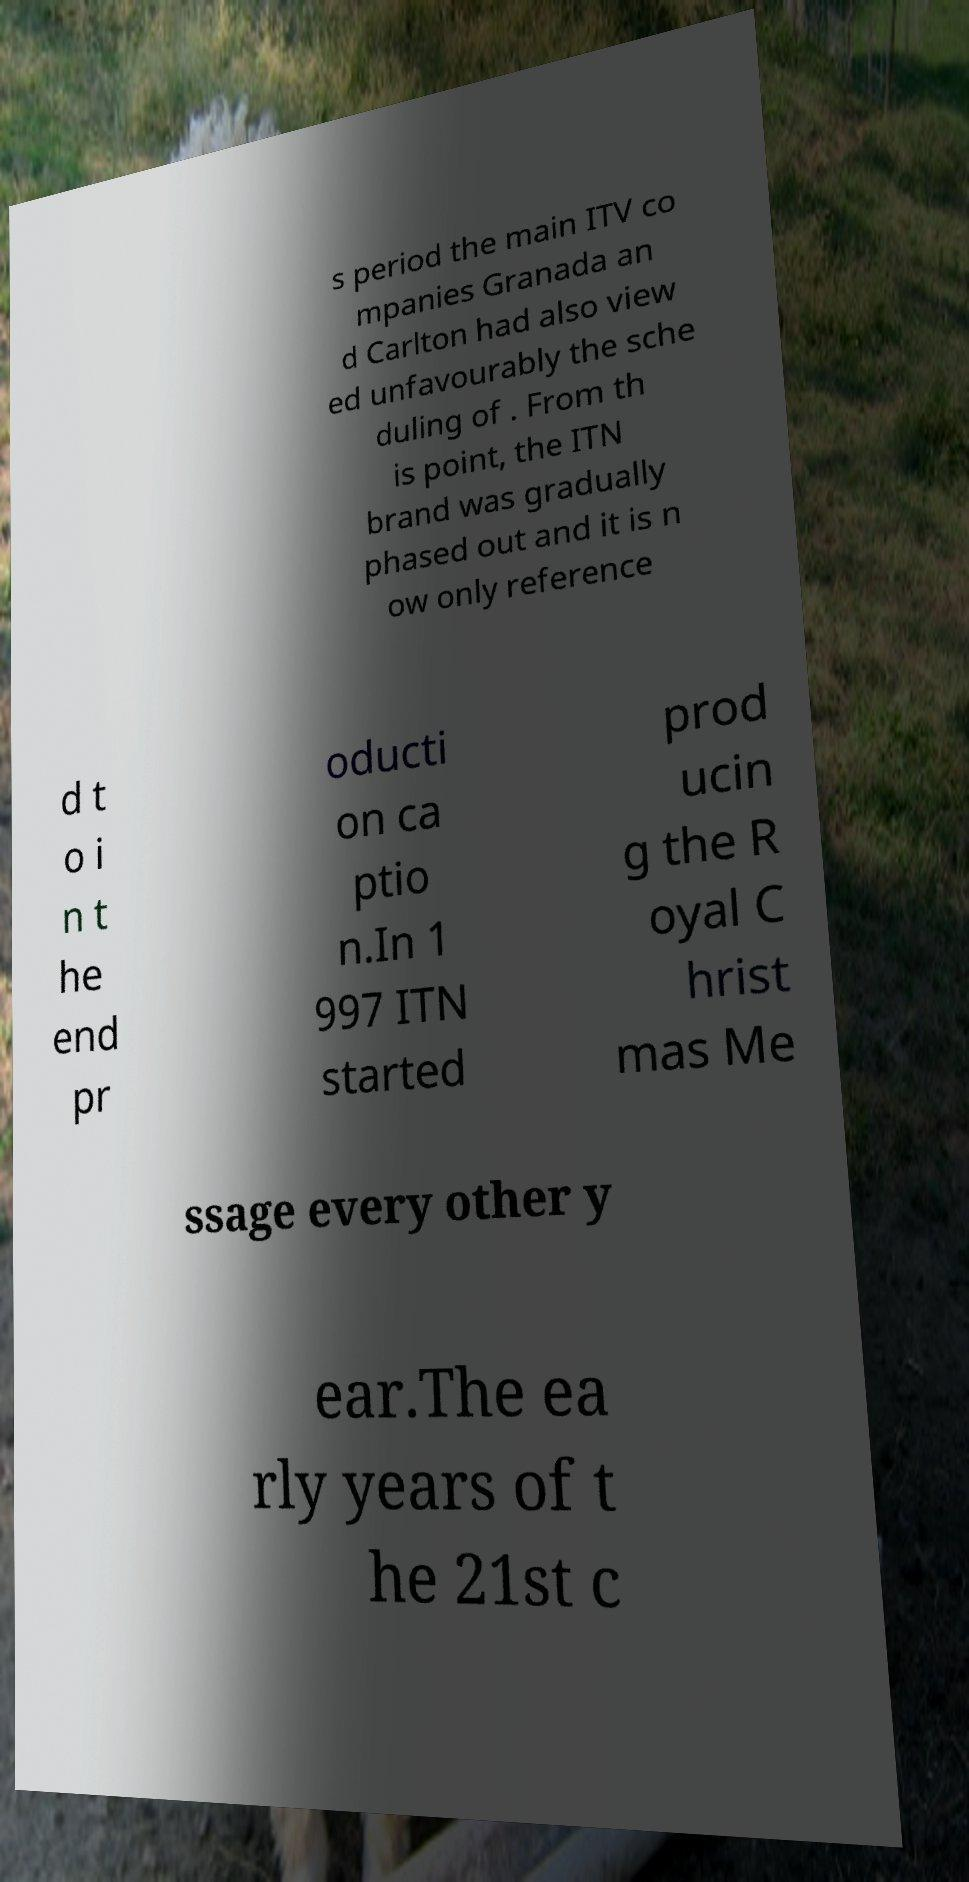Could you extract and type out the text from this image? s period the main ITV co mpanies Granada an d Carlton had also view ed unfavourably the sche duling of . From th is point, the ITN brand was gradually phased out and it is n ow only reference d t o i n t he end pr oducti on ca ptio n.In 1 997 ITN started prod ucin g the R oyal C hrist mas Me ssage every other y ear.The ea rly years of t he 21st c 